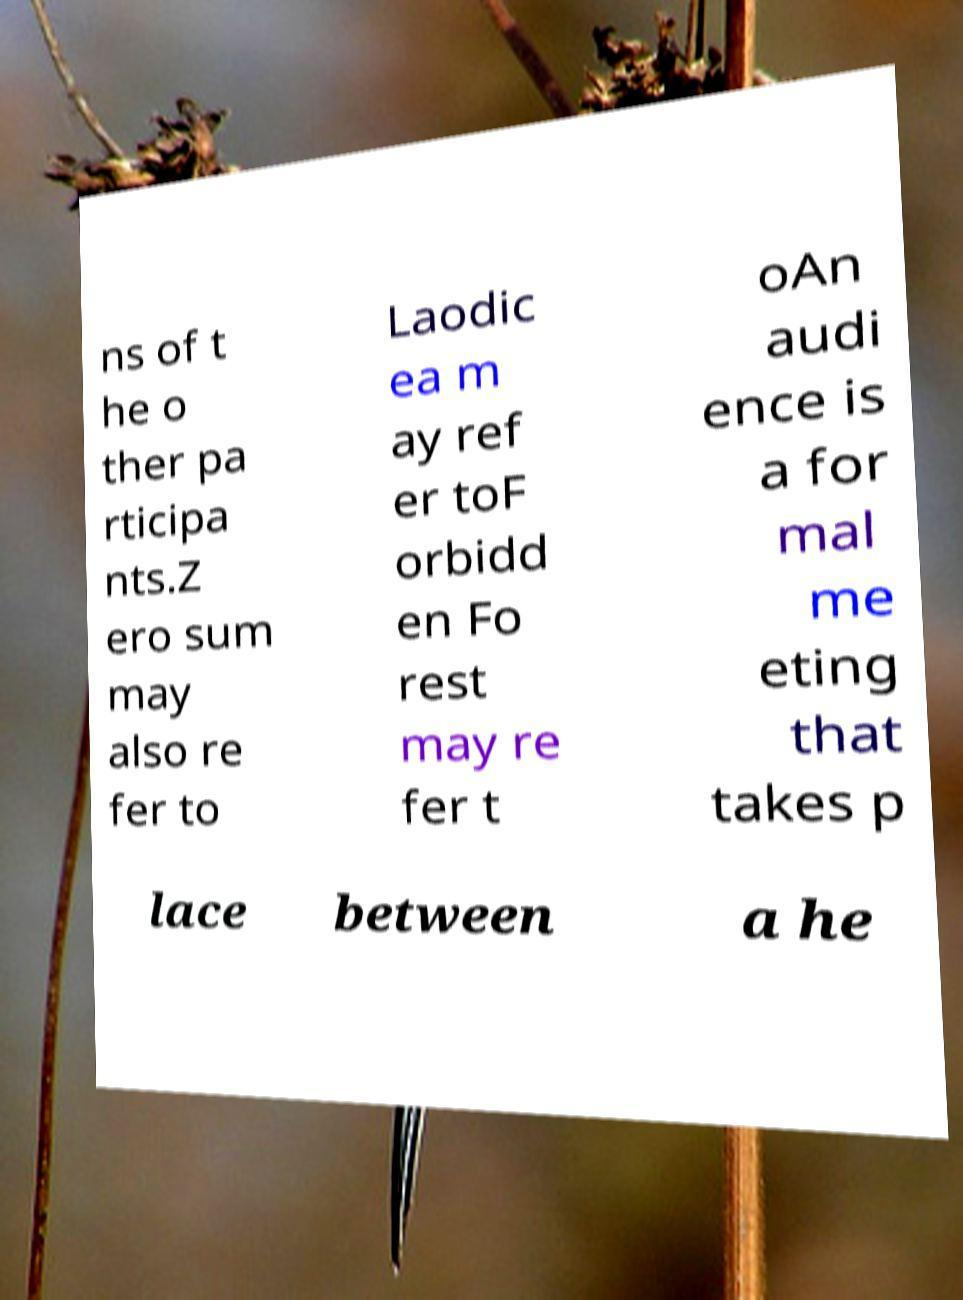There's text embedded in this image that I need extracted. Can you transcribe it verbatim? ns of t he o ther pa rticipa nts.Z ero sum may also re fer to Laodic ea m ay ref er toF orbidd en Fo rest may re fer t oAn audi ence is a for mal me eting that takes p lace between a he 